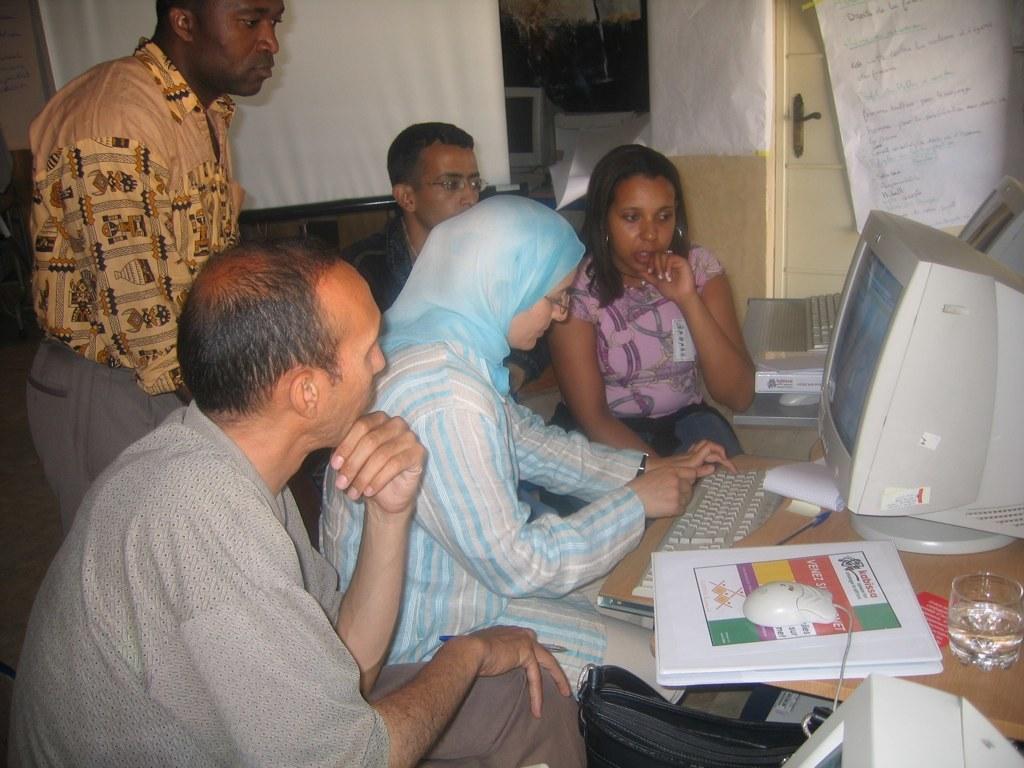How would you summarize this image in a sentence or two? This picture is clicked inside. On the right there is a wooden table on the top of which we can see the monitors, keyboards, mouse, glass of water, book and some other items are placed. On the left we can see the group of persons sitting and there is a person wearing shirt and standing on the ground. In the background we can see the wall, door and some other objects. 